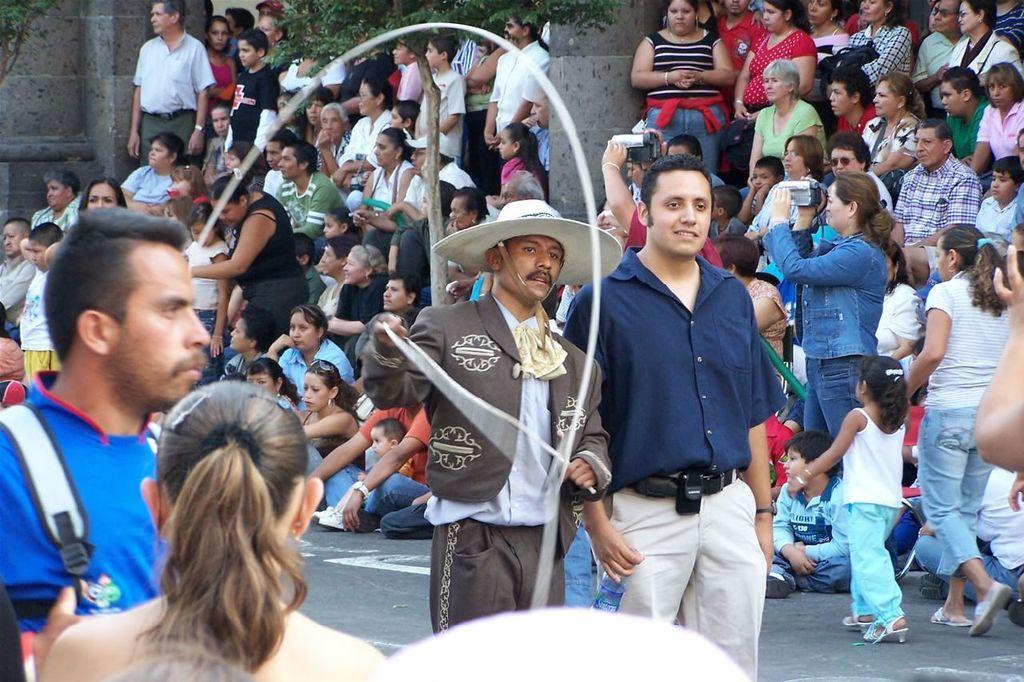Could you give a brief overview of what you see in this image? In this image there are a group of persons sitting, there are a group of persons standing, there are persons holding an object, there is a road, there is a woman walking on the road, there is a girl walking on the road, there are two men walking on the road, there is a man wearing a hat and holding an object, there is an object towards the bottom of the image, there is a woman towards the bottom of the image, there is a man towards the left of the image, he is wearing a bag, there is a plant towards the top of the image, there is a wall towards the top of the image, there is a person's hand towards the right of the image. 